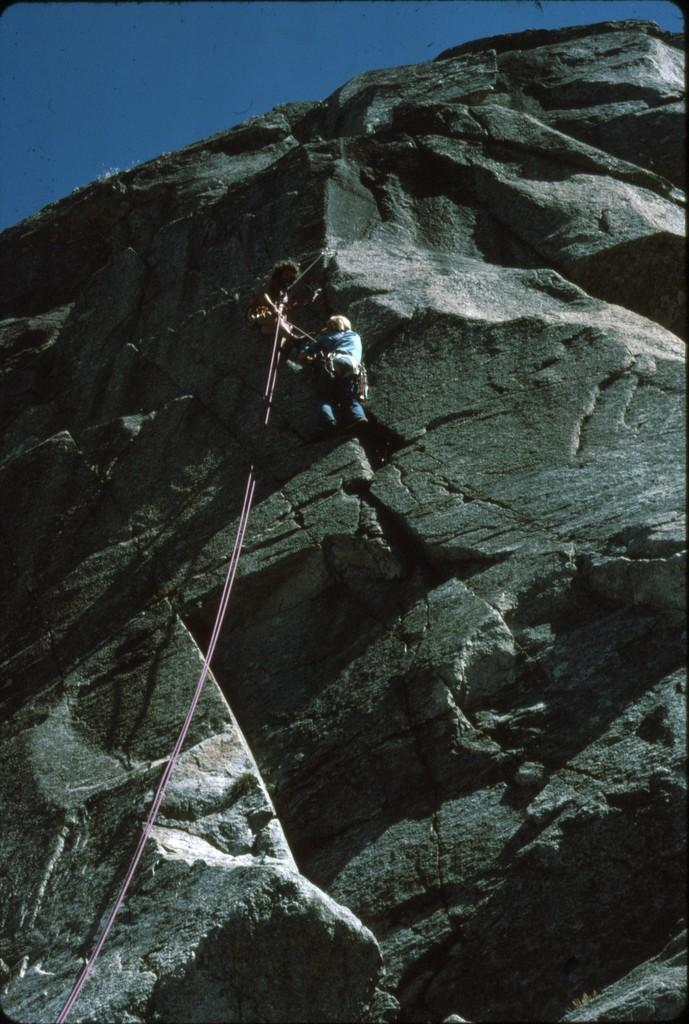What is the main subject of the image? There is a man in the image. What is the man doing in the image? The man is climbing a rock. What type of square can be seen on the stove in the image? There is no square or stove present in the image; it features a man climbing a rock. 